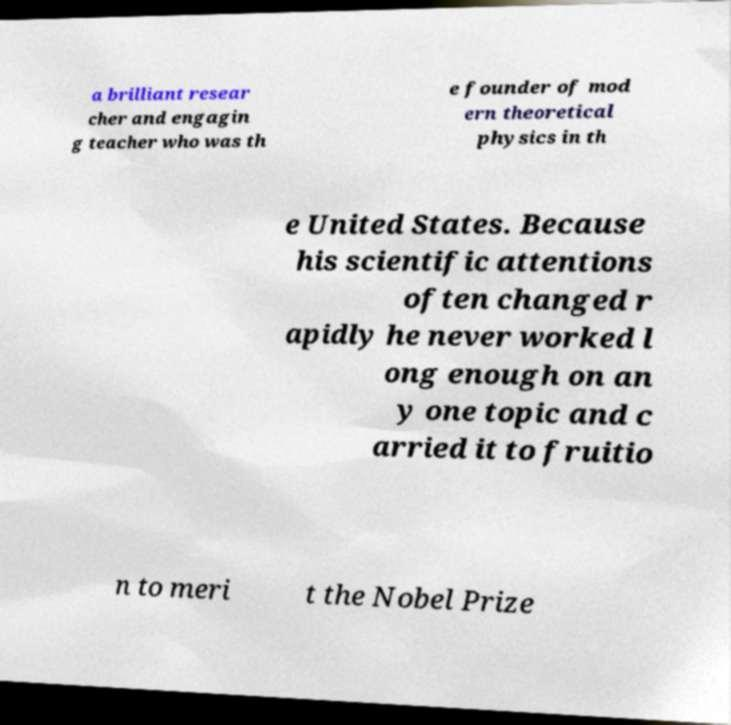Could you extract and type out the text from this image? a brilliant resear cher and engagin g teacher who was th e founder of mod ern theoretical physics in th e United States. Because his scientific attentions often changed r apidly he never worked l ong enough on an y one topic and c arried it to fruitio n to meri t the Nobel Prize 